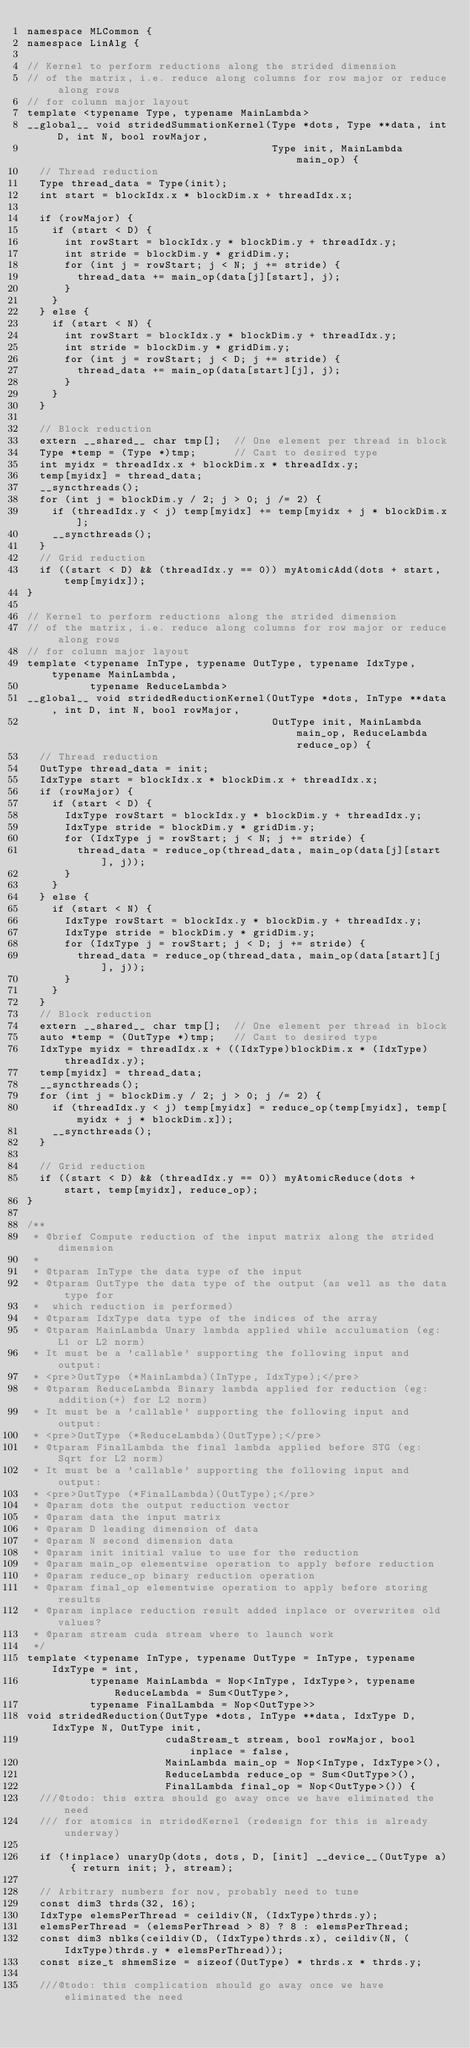<code> <loc_0><loc_0><loc_500><loc_500><_Cuda_>namespace MLCommon {
namespace LinAlg {

// Kernel to perform reductions along the strided dimension
// of the matrix, i.e. reduce along columns for row major or reduce along rows
// for column major layout
template <typename Type, typename MainLambda>
__global__ void stridedSummationKernel(Type *dots, Type **data, int D, int N, bool rowMajor,
                                       Type init, MainLambda main_op) {
  // Thread reduction
  Type thread_data = Type(init);
  int start = blockIdx.x * blockDim.x + threadIdx.x;

  if (rowMajor) {
    if (start < D) {
      int rowStart = blockIdx.y * blockDim.y + threadIdx.y;
      int stride = blockDim.y * gridDim.y;
      for (int j = rowStart; j < N; j += stride) {
        thread_data += main_op(data[j][start], j);
      }
    }
  } else {
    if (start < N) {
      int rowStart = blockIdx.y * blockDim.y + threadIdx.y;
      int stride = blockDim.y * gridDim.y;
      for (int j = rowStart; j < D; j += stride) {
        thread_data += main_op(data[start][j], j);
      }
    }
  }

  // Block reduction
  extern __shared__ char tmp[];  // One element per thread in block
  Type *temp = (Type *)tmp;      // Cast to desired type
  int myidx = threadIdx.x + blockDim.x * threadIdx.y;
  temp[myidx] = thread_data;
  __syncthreads();
  for (int j = blockDim.y / 2; j > 0; j /= 2) {
    if (threadIdx.y < j) temp[myidx] += temp[myidx + j * blockDim.x];
    __syncthreads();
  }
  // Grid reduction
  if ((start < D) && (threadIdx.y == 0)) myAtomicAdd(dots + start, temp[myidx]);
}

// Kernel to perform reductions along the strided dimension
// of the matrix, i.e. reduce along columns for row major or reduce along rows
// for column major layout
template <typename InType, typename OutType, typename IdxType, typename MainLambda,
          typename ReduceLambda>
__global__ void stridedReductionKernel(OutType *dots, InType **data, int D, int N, bool rowMajor,
                                       OutType init, MainLambda main_op, ReduceLambda reduce_op) {
  // Thread reduction
  OutType thread_data = init;
  IdxType start = blockIdx.x * blockDim.x + threadIdx.x;
  if (rowMajor) {
    if (start < D) {
      IdxType rowStart = blockIdx.y * blockDim.y + threadIdx.y;
      IdxType stride = blockDim.y * gridDim.y;
      for (IdxType j = rowStart; j < N; j += stride) {
        thread_data = reduce_op(thread_data, main_op(data[j][start], j));
      }
    }
  } else {
    if (start < N) {
      IdxType rowStart = blockIdx.y * blockDim.y + threadIdx.y;
      IdxType stride = blockDim.y * gridDim.y;
      for (IdxType j = rowStart; j < D; j += stride) {
        thread_data = reduce_op(thread_data, main_op(data[start][j], j));
      }
    }
  }
  // Block reduction
  extern __shared__ char tmp[];  // One element per thread in block
  auto *temp = (OutType *)tmp;   // Cast to desired type
  IdxType myidx = threadIdx.x + ((IdxType)blockDim.x * (IdxType)threadIdx.y);
  temp[myidx] = thread_data;
  __syncthreads();
  for (int j = blockDim.y / 2; j > 0; j /= 2) {
    if (threadIdx.y < j) temp[myidx] = reduce_op(temp[myidx], temp[myidx + j * blockDim.x]);
    __syncthreads();
  }

  // Grid reduction
  if ((start < D) && (threadIdx.y == 0)) myAtomicReduce(dots + start, temp[myidx], reduce_op);
}

/**
 * @brief Compute reduction of the input matrix along the strided dimension
 *
 * @tparam InType the data type of the input
 * @tparam OutType the data type of the output (as well as the data type for
 *  which reduction is performed)
 * @tparam IdxType data type of the indices of the array
 * @tparam MainLambda Unary lambda applied while acculumation (eg: L1 or L2 norm)
 * It must be a 'callable' supporting the following input and output:
 * <pre>OutType (*MainLambda)(InType, IdxType);</pre>
 * @tparam ReduceLambda Binary lambda applied for reduction (eg: addition(+) for L2 norm)
 * It must be a 'callable' supporting the following input and output:
 * <pre>OutType (*ReduceLambda)(OutType);</pre>
 * @tparam FinalLambda the final lambda applied before STG (eg: Sqrt for L2 norm)
 * It must be a 'callable' supporting the following input and output:
 * <pre>OutType (*FinalLambda)(OutType);</pre>
 * @param dots the output reduction vector
 * @param data the input matrix
 * @param D leading dimension of data
 * @param N second dimension data
 * @param init initial value to use for the reduction
 * @param main_op elementwise operation to apply before reduction
 * @param reduce_op binary reduction operation
 * @param final_op elementwise operation to apply before storing results
 * @param inplace reduction result added inplace or overwrites old values?
 * @param stream cuda stream where to launch work
 */
template <typename InType, typename OutType = InType, typename IdxType = int,
          typename MainLambda = Nop<InType, IdxType>, typename ReduceLambda = Sum<OutType>,
          typename FinalLambda = Nop<OutType>>
void stridedReduction(OutType *dots, InType **data, IdxType D, IdxType N, OutType init,
                      cudaStream_t stream, bool rowMajor, bool inplace = false,
                      MainLambda main_op = Nop<InType, IdxType>(),
                      ReduceLambda reduce_op = Sum<OutType>(),
                      FinalLambda final_op = Nop<OutType>()) {
  ///@todo: this extra should go away once we have eliminated the need
  /// for atomics in stridedKernel (redesign for this is already underway)

  if (!inplace) unaryOp(dots, dots, D, [init] __device__(OutType a) { return init; }, stream);

  // Arbitrary numbers for now, probably need to tune
  const dim3 thrds(32, 16);
  IdxType elemsPerThread = ceildiv(N, (IdxType)thrds.y);
  elemsPerThread = (elemsPerThread > 8) ? 8 : elemsPerThread;
  const dim3 nblks(ceildiv(D, (IdxType)thrds.x), ceildiv(N, (IdxType)thrds.y * elemsPerThread));
  const size_t shmemSize = sizeof(OutType) * thrds.x * thrds.y;

  ///@todo: this complication should go away once we have eliminated the need</code> 